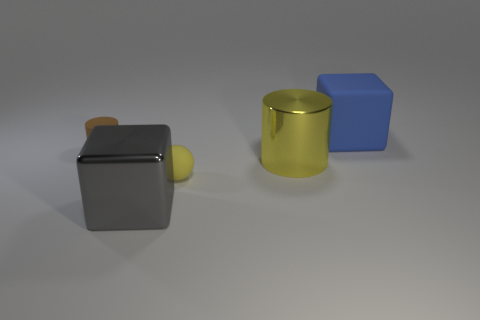Add 1 small gray metal things. How many objects exist? 6 Subtract all cylinders. How many objects are left? 3 Subtract 0 yellow cubes. How many objects are left? 5 Subtract all gray things. Subtract all big yellow matte cylinders. How many objects are left? 4 Add 2 small matte spheres. How many small matte spheres are left? 3 Add 1 large things. How many large things exist? 4 